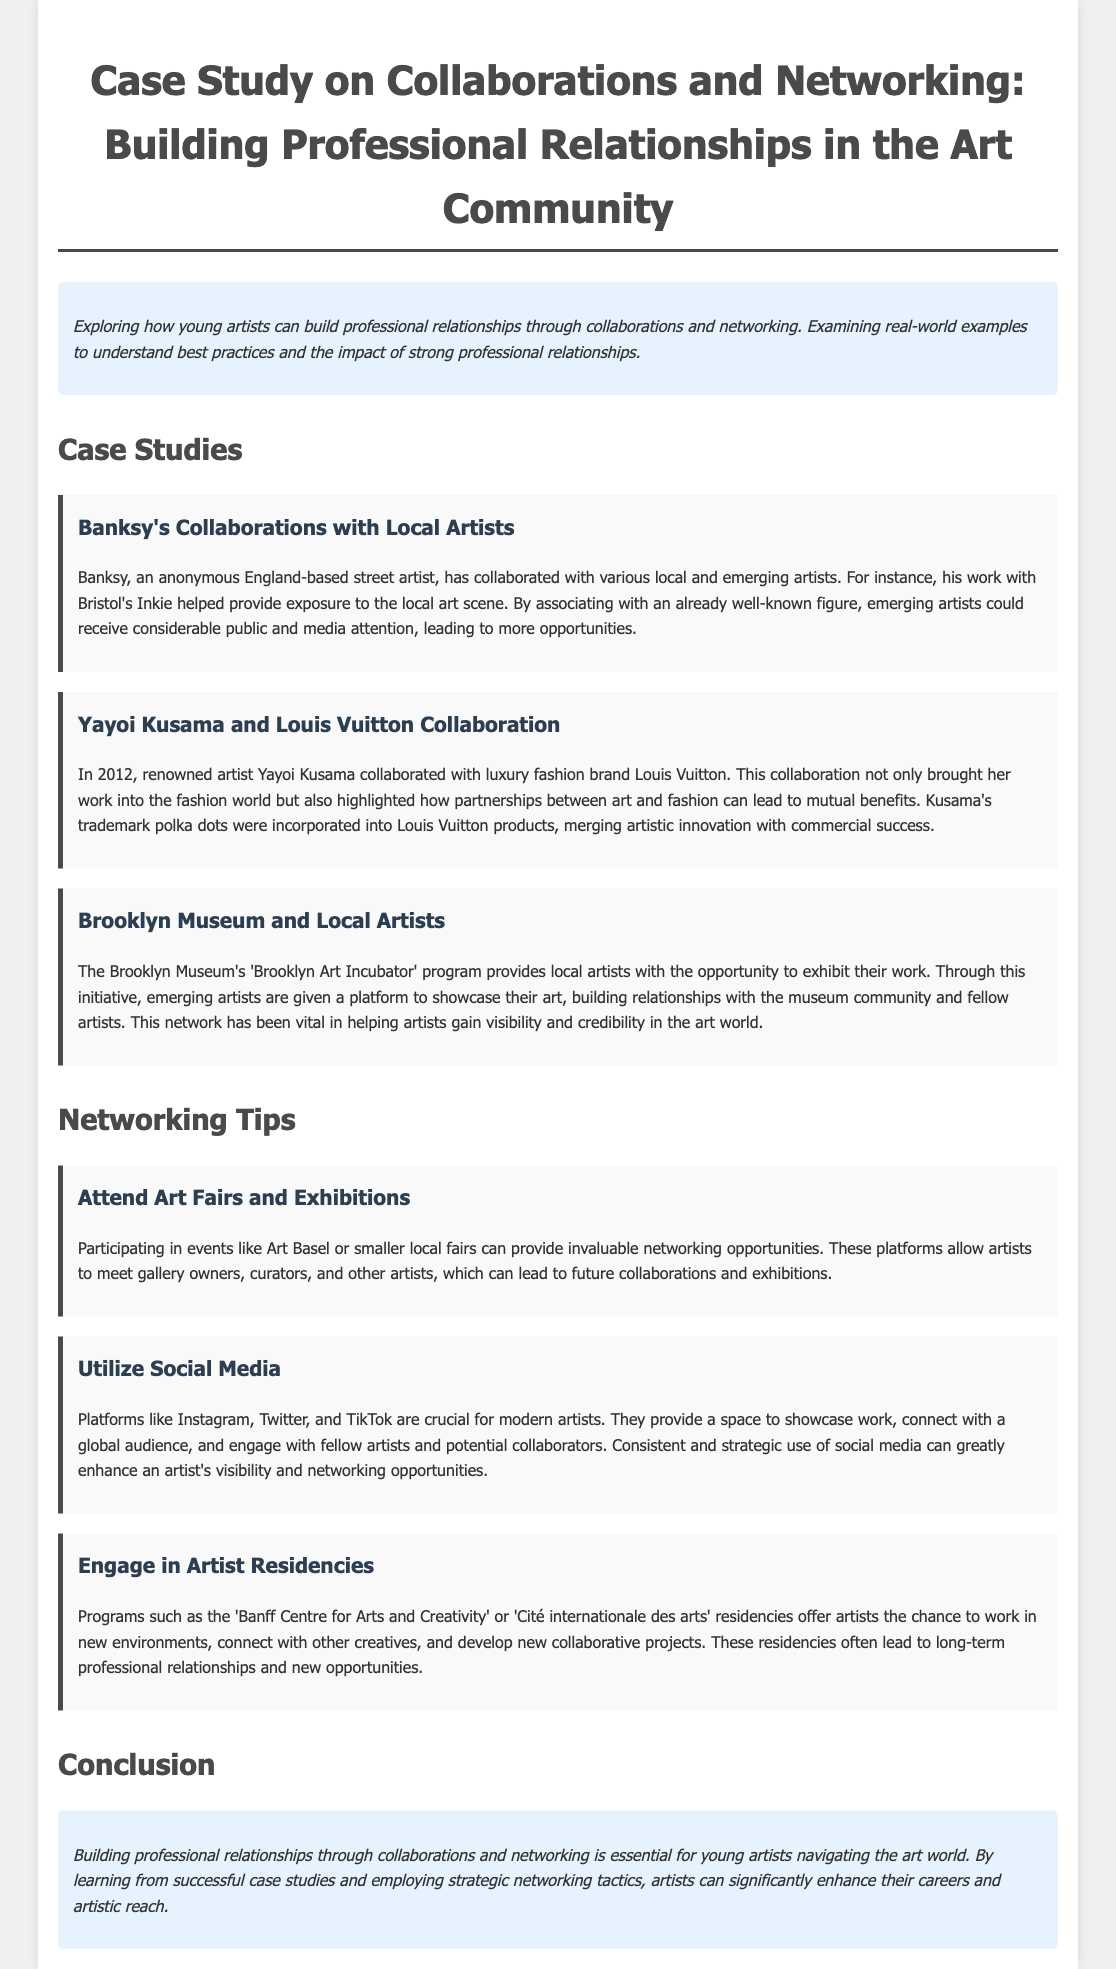What is the title of the case study? The title of the case study is listed at the top of the document.
Answer: Case Study on Collaborations and Networking: Building Professional Relationships in the Art Community Who collaborated with Banksy to provide exposure to the local art scene? The document mentions an example of collaboration with Banksy that highlights local artists.
Answer: Inkie In what year did Yayoi Kusama collaborate with Louis Vuitton? The text specifies the year of the collaboration in a case study.
Answer: 2012 What program helps local artists exhibit their work at the Brooklyn Museum? The document provides the name of the program in the case study about the Brooklyn Museum.
Answer: Brooklyn Art Incubator Which social media platforms are mentioned as crucial for modern artists? The networking tips discuss social media platforms that enhance visibility for artists.
Answer: Instagram, Twitter, and TikTok What is one benefit of attending art fairs and exhibitions? The networking tips describe the advantages of participating in specific art-related events.
Answer: Networking opportunities How do artist residencies facilitate professional relationships? The document explains the role of artist residencies in connecting creatives through new environments.
Answer: Long-term professional relationships Which case study demonstrates the collaboration between art and fashion? The document indicates a specific case study that showcases a mix of two industries.
Answer: Yayoi Kusama and Louis Vuitton Collaboration 